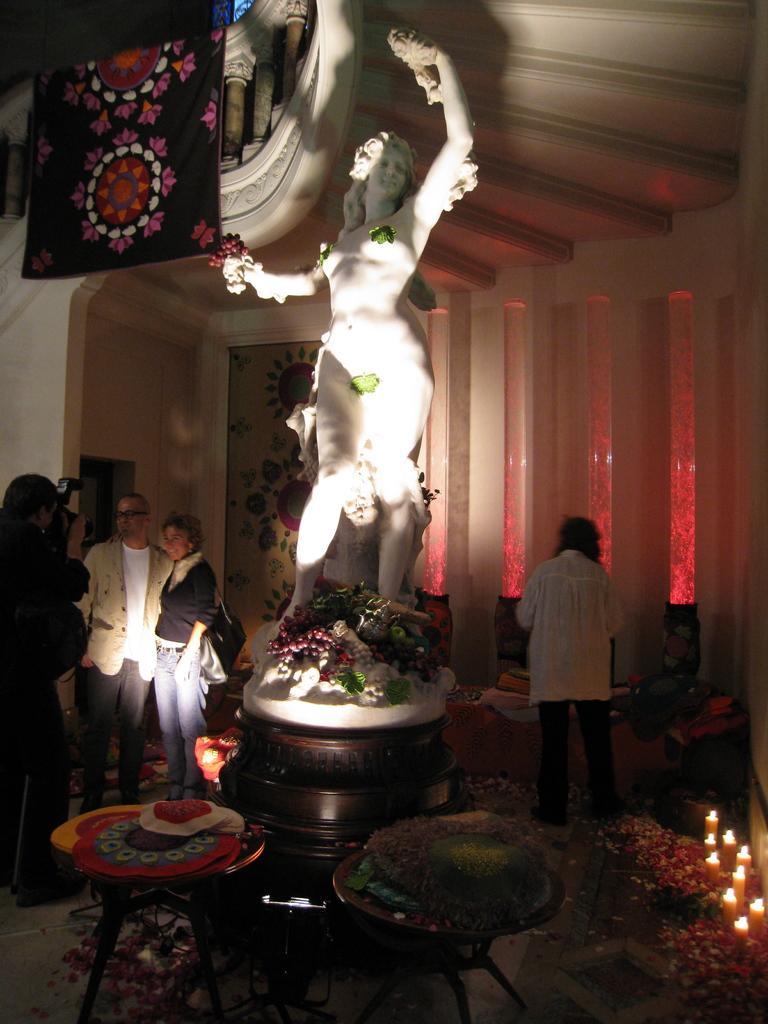In one or two sentences, can you explain what this image depicts? In the middle we can see the statue and on the left side we can see the three people were standing,and one fellow is holding the camera. And coming to the right side one person is standing. And the background there is a wall. 